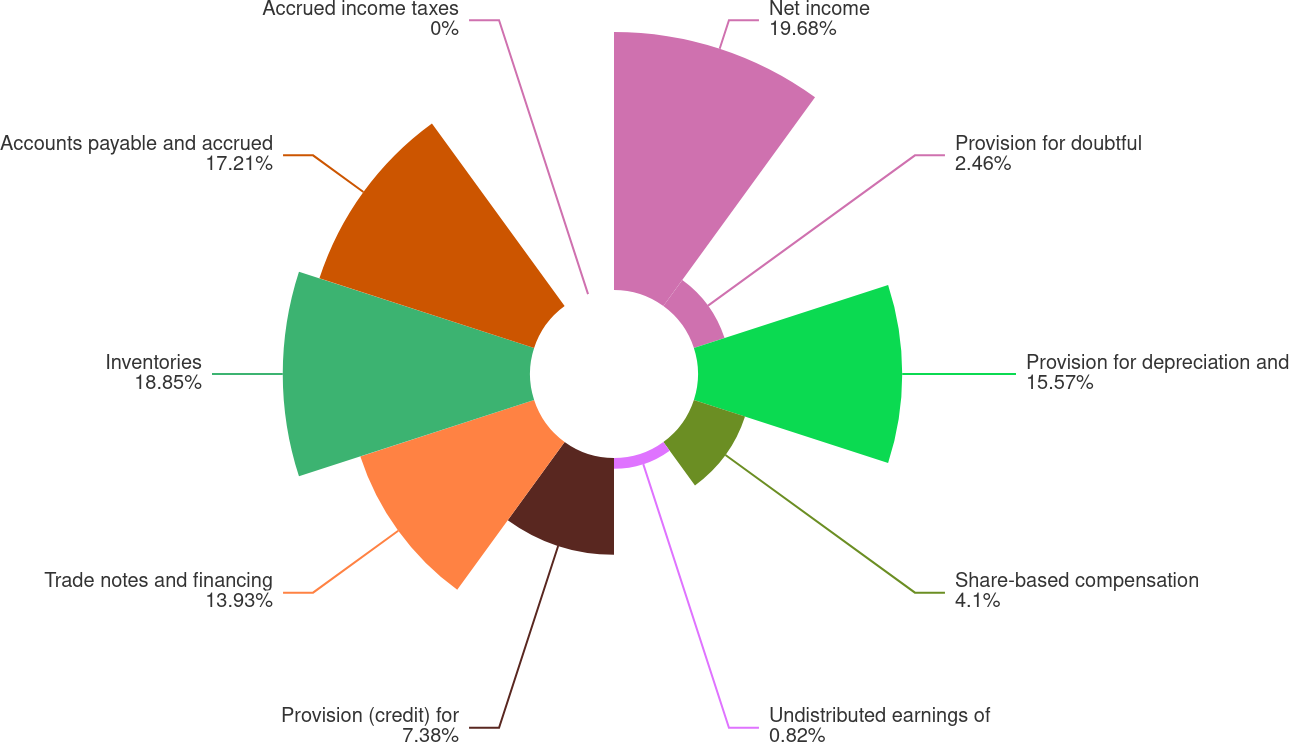<chart> <loc_0><loc_0><loc_500><loc_500><pie_chart><fcel>Net income<fcel>Provision for doubtful<fcel>Provision for depreciation and<fcel>Share-based compensation<fcel>Undistributed earnings of<fcel>Provision (credit) for<fcel>Trade notes and financing<fcel>Inventories<fcel>Accounts payable and accrued<fcel>Accrued income taxes<nl><fcel>19.67%<fcel>2.46%<fcel>15.57%<fcel>4.1%<fcel>0.82%<fcel>7.38%<fcel>13.93%<fcel>18.85%<fcel>17.21%<fcel>0.0%<nl></chart> 